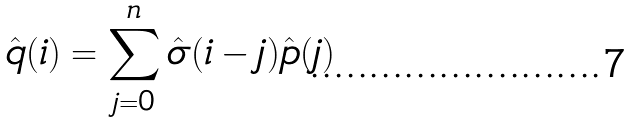Convert formula to latex. <formula><loc_0><loc_0><loc_500><loc_500>\hat { q } ( i ) = \sum _ { j = 0 } ^ { n } \hat { \sigma } ( i - j ) \hat { p } ( j )</formula> 